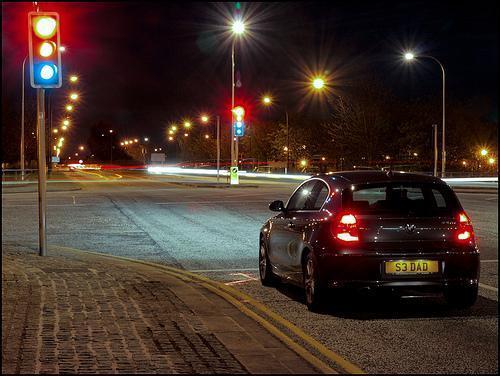How many beds are in the room?
Give a very brief answer. 0. 